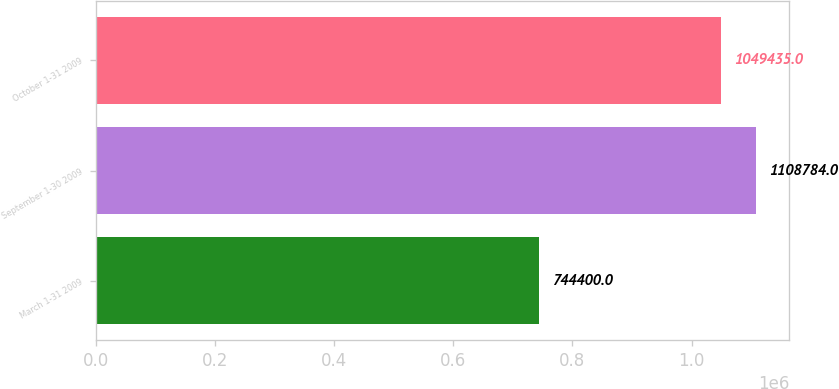Convert chart. <chart><loc_0><loc_0><loc_500><loc_500><bar_chart><fcel>March 1-31 2009<fcel>September 1-30 2009<fcel>October 1-31 2009<nl><fcel>744400<fcel>1.10878e+06<fcel>1.04944e+06<nl></chart> 